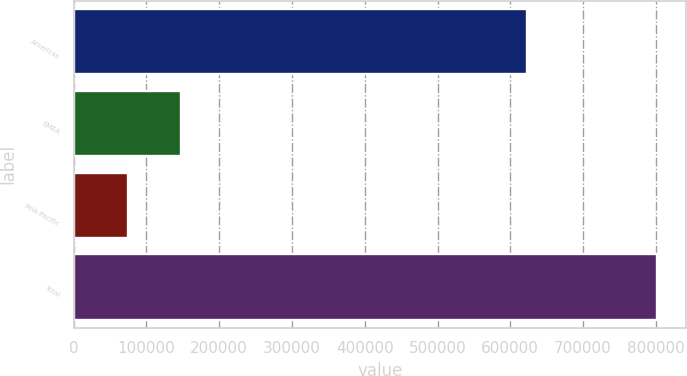Convert chart to OTSL. <chart><loc_0><loc_0><loc_500><loc_500><bar_chart><fcel>Americas<fcel>EMEA<fcel>Asia-Pacific<fcel>Total<nl><fcel>622556<fcel>147473<fcel>74802<fcel>801510<nl></chart> 